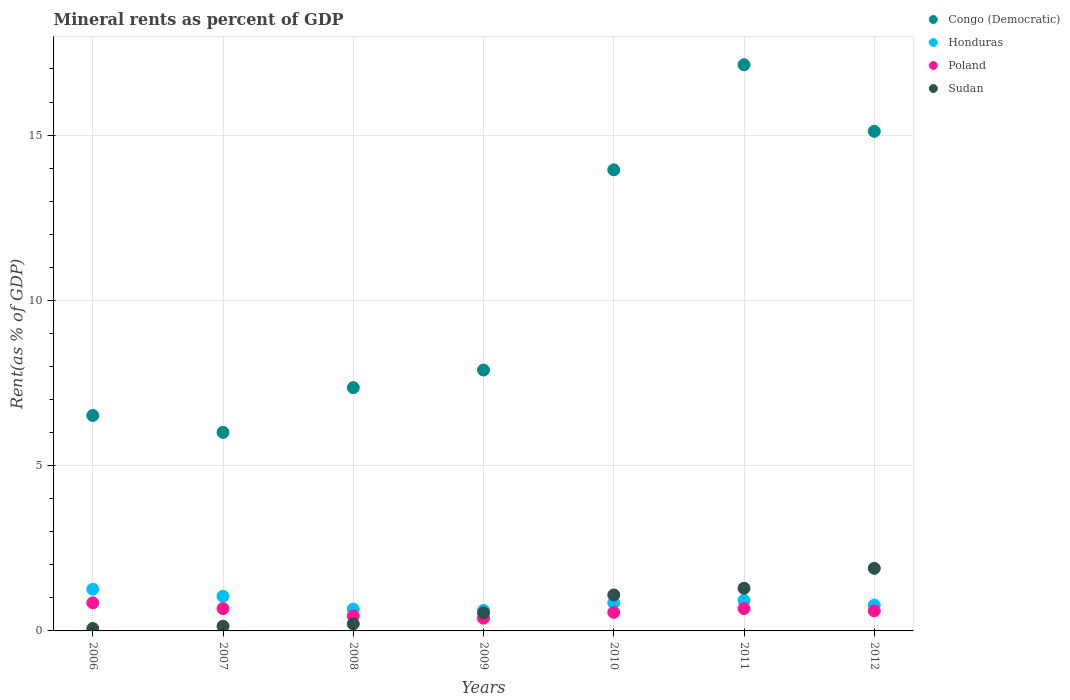How many different coloured dotlines are there?
Provide a succinct answer. 4. What is the mineral rent in Poland in 2006?
Ensure brevity in your answer.  0.85. Across all years, what is the maximum mineral rent in Poland?
Keep it short and to the point. 0.85. Across all years, what is the minimum mineral rent in Congo (Democratic)?
Keep it short and to the point. 6.01. What is the total mineral rent in Congo (Democratic) in the graph?
Ensure brevity in your answer.  73.96. What is the difference between the mineral rent in Congo (Democratic) in 2011 and that in 2012?
Your answer should be very brief. 2.01. What is the difference between the mineral rent in Sudan in 2011 and the mineral rent in Honduras in 2008?
Give a very brief answer. 0.63. What is the average mineral rent in Poland per year?
Your answer should be compact. 0.6. In the year 2010, what is the difference between the mineral rent in Honduras and mineral rent in Poland?
Provide a succinct answer. 0.29. What is the ratio of the mineral rent in Honduras in 2008 to that in 2009?
Offer a very short reply. 1.06. Is the mineral rent in Sudan in 2011 less than that in 2012?
Offer a very short reply. Yes. What is the difference between the highest and the second highest mineral rent in Honduras?
Provide a short and direct response. 0.21. What is the difference between the highest and the lowest mineral rent in Honduras?
Provide a short and direct response. 0.64. Is it the case that in every year, the sum of the mineral rent in Poland and mineral rent in Congo (Democratic)  is greater than the sum of mineral rent in Sudan and mineral rent in Honduras?
Provide a succinct answer. Yes. How many dotlines are there?
Ensure brevity in your answer.  4. Are the values on the major ticks of Y-axis written in scientific E-notation?
Ensure brevity in your answer.  No. Does the graph contain any zero values?
Make the answer very short. No. Does the graph contain grids?
Make the answer very short. Yes. Where does the legend appear in the graph?
Offer a terse response. Top right. How are the legend labels stacked?
Your answer should be compact. Vertical. What is the title of the graph?
Your response must be concise. Mineral rents as percent of GDP. What is the label or title of the Y-axis?
Keep it short and to the point. Rent(as % of GDP). What is the Rent(as % of GDP) in Congo (Democratic) in 2006?
Your answer should be very brief. 6.52. What is the Rent(as % of GDP) in Honduras in 2006?
Offer a terse response. 1.26. What is the Rent(as % of GDP) of Poland in 2006?
Your answer should be very brief. 0.85. What is the Rent(as % of GDP) of Sudan in 2006?
Offer a terse response. 0.07. What is the Rent(as % of GDP) in Congo (Democratic) in 2007?
Keep it short and to the point. 6.01. What is the Rent(as % of GDP) of Honduras in 2007?
Provide a succinct answer. 1.05. What is the Rent(as % of GDP) of Poland in 2007?
Give a very brief answer. 0.68. What is the Rent(as % of GDP) of Sudan in 2007?
Keep it short and to the point. 0.14. What is the Rent(as % of GDP) of Congo (Democratic) in 2008?
Make the answer very short. 7.36. What is the Rent(as % of GDP) of Honduras in 2008?
Keep it short and to the point. 0.66. What is the Rent(as % of GDP) in Poland in 2008?
Your answer should be very brief. 0.46. What is the Rent(as % of GDP) of Sudan in 2008?
Provide a short and direct response. 0.21. What is the Rent(as % of GDP) of Congo (Democratic) in 2009?
Offer a very short reply. 7.89. What is the Rent(as % of GDP) in Honduras in 2009?
Offer a very short reply. 0.62. What is the Rent(as % of GDP) in Poland in 2009?
Give a very brief answer. 0.39. What is the Rent(as % of GDP) in Sudan in 2009?
Offer a terse response. 0.55. What is the Rent(as % of GDP) in Congo (Democratic) in 2010?
Make the answer very short. 13.95. What is the Rent(as % of GDP) in Honduras in 2010?
Provide a short and direct response. 0.85. What is the Rent(as % of GDP) of Poland in 2010?
Provide a short and direct response. 0.56. What is the Rent(as % of GDP) in Sudan in 2010?
Ensure brevity in your answer.  1.09. What is the Rent(as % of GDP) in Congo (Democratic) in 2011?
Your response must be concise. 17.13. What is the Rent(as % of GDP) of Honduras in 2011?
Your answer should be compact. 0.92. What is the Rent(as % of GDP) of Poland in 2011?
Keep it short and to the point. 0.68. What is the Rent(as % of GDP) of Sudan in 2011?
Offer a terse response. 1.29. What is the Rent(as % of GDP) of Congo (Democratic) in 2012?
Keep it short and to the point. 15.11. What is the Rent(as % of GDP) of Honduras in 2012?
Offer a very short reply. 0.78. What is the Rent(as % of GDP) in Poland in 2012?
Your response must be concise. 0.61. What is the Rent(as % of GDP) in Sudan in 2012?
Ensure brevity in your answer.  1.89. Across all years, what is the maximum Rent(as % of GDP) in Congo (Democratic)?
Provide a succinct answer. 17.13. Across all years, what is the maximum Rent(as % of GDP) in Honduras?
Offer a very short reply. 1.26. Across all years, what is the maximum Rent(as % of GDP) of Poland?
Provide a short and direct response. 0.85. Across all years, what is the maximum Rent(as % of GDP) in Sudan?
Your response must be concise. 1.89. Across all years, what is the minimum Rent(as % of GDP) of Congo (Democratic)?
Offer a very short reply. 6.01. Across all years, what is the minimum Rent(as % of GDP) of Honduras?
Offer a very short reply. 0.62. Across all years, what is the minimum Rent(as % of GDP) of Poland?
Provide a short and direct response. 0.39. Across all years, what is the minimum Rent(as % of GDP) in Sudan?
Offer a terse response. 0.07. What is the total Rent(as % of GDP) of Congo (Democratic) in the graph?
Ensure brevity in your answer.  73.96. What is the total Rent(as % of GDP) of Honduras in the graph?
Offer a terse response. 6.15. What is the total Rent(as % of GDP) of Poland in the graph?
Your answer should be compact. 4.21. What is the total Rent(as % of GDP) of Sudan in the graph?
Your answer should be compact. 5.25. What is the difference between the Rent(as % of GDP) of Congo (Democratic) in 2006 and that in 2007?
Keep it short and to the point. 0.51. What is the difference between the Rent(as % of GDP) of Honduras in 2006 and that in 2007?
Give a very brief answer. 0.21. What is the difference between the Rent(as % of GDP) of Poland in 2006 and that in 2007?
Give a very brief answer. 0.17. What is the difference between the Rent(as % of GDP) in Sudan in 2006 and that in 2007?
Your answer should be compact. -0.07. What is the difference between the Rent(as % of GDP) in Congo (Democratic) in 2006 and that in 2008?
Give a very brief answer. -0.84. What is the difference between the Rent(as % of GDP) of Honduras in 2006 and that in 2008?
Your answer should be very brief. 0.6. What is the difference between the Rent(as % of GDP) in Poland in 2006 and that in 2008?
Your answer should be very brief. 0.39. What is the difference between the Rent(as % of GDP) of Sudan in 2006 and that in 2008?
Your response must be concise. -0.14. What is the difference between the Rent(as % of GDP) in Congo (Democratic) in 2006 and that in 2009?
Provide a succinct answer. -1.37. What is the difference between the Rent(as % of GDP) of Honduras in 2006 and that in 2009?
Offer a very short reply. 0.64. What is the difference between the Rent(as % of GDP) in Poland in 2006 and that in 2009?
Keep it short and to the point. 0.46. What is the difference between the Rent(as % of GDP) in Sudan in 2006 and that in 2009?
Offer a terse response. -0.47. What is the difference between the Rent(as % of GDP) of Congo (Democratic) in 2006 and that in 2010?
Your answer should be very brief. -7.43. What is the difference between the Rent(as % of GDP) in Honduras in 2006 and that in 2010?
Your answer should be compact. 0.41. What is the difference between the Rent(as % of GDP) of Poland in 2006 and that in 2010?
Offer a very short reply. 0.29. What is the difference between the Rent(as % of GDP) in Sudan in 2006 and that in 2010?
Offer a very short reply. -1.01. What is the difference between the Rent(as % of GDP) of Congo (Democratic) in 2006 and that in 2011?
Your answer should be very brief. -10.61. What is the difference between the Rent(as % of GDP) of Honduras in 2006 and that in 2011?
Your response must be concise. 0.34. What is the difference between the Rent(as % of GDP) in Poland in 2006 and that in 2011?
Provide a succinct answer. 0.17. What is the difference between the Rent(as % of GDP) of Sudan in 2006 and that in 2011?
Give a very brief answer. -1.22. What is the difference between the Rent(as % of GDP) in Congo (Democratic) in 2006 and that in 2012?
Give a very brief answer. -8.6. What is the difference between the Rent(as % of GDP) of Honduras in 2006 and that in 2012?
Ensure brevity in your answer.  0.48. What is the difference between the Rent(as % of GDP) in Poland in 2006 and that in 2012?
Provide a short and direct response. 0.24. What is the difference between the Rent(as % of GDP) of Sudan in 2006 and that in 2012?
Keep it short and to the point. -1.82. What is the difference between the Rent(as % of GDP) of Congo (Democratic) in 2007 and that in 2008?
Your answer should be compact. -1.35. What is the difference between the Rent(as % of GDP) in Honduras in 2007 and that in 2008?
Offer a terse response. 0.39. What is the difference between the Rent(as % of GDP) of Poland in 2007 and that in 2008?
Your answer should be very brief. 0.22. What is the difference between the Rent(as % of GDP) of Sudan in 2007 and that in 2008?
Your response must be concise. -0.07. What is the difference between the Rent(as % of GDP) in Congo (Democratic) in 2007 and that in 2009?
Ensure brevity in your answer.  -1.89. What is the difference between the Rent(as % of GDP) in Honduras in 2007 and that in 2009?
Keep it short and to the point. 0.43. What is the difference between the Rent(as % of GDP) in Poland in 2007 and that in 2009?
Offer a very short reply. 0.29. What is the difference between the Rent(as % of GDP) in Sudan in 2007 and that in 2009?
Give a very brief answer. -0.41. What is the difference between the Rent(as % of GDP) of Congo (Democratic) in 2007 and that in 2010?
Offer a terse response. -7.94. What is the difference between the Rent(as % of GDP) of Honduras in 2007 and that in 2010?
Your answer should be compact. 0.2. What is the difference between the Rent(as % of GDP) in Poland in 2007 and that in 2010?
Provide a short and direct response. 0.11. What is the difference between the Rent(as % of GDP) in Sudan in 2007 and that in 2010?
Your answer should be compact. -0.95. What is the difference between the Rent(as % of GDP) of Congo (Democratic) in 2007 and that in 2011?
Ensure brevity in your answer.  -11.12. What is the difference between the Rent(as % of GDP) of Honduras in 2007 and that in 2011?
Ensure brevity in your answer.  0.13. What is the difference between the Rent(as % of GDP) of Poland in 2007 and that in 2011?
Offer a very short reply. -0. What is the difference between the Rent(as % of GDP) in Sudan in 2007 and that in 2011?
Your answer should be compact. -1.15. What is the difference between the Rent(as % of GDP) of Congo (Democratic) in 2007 and that in 2012?
Your response must be concise. -9.11. What is the difference between the Rent(as % of GDP) in Honduras in 2007 and that in 2012?
Make the answer very short. 0.27. What is the difference between the Rent(as % of GDP) of Poland in 2007 and that in 2012?
Your answer should be very brief. 0.07. What is the difference between the Rent(as % of GDP) in Sudan in 2007 and that in 2012?
Your answer should be very brief. -1.75. What is the difference between the Rent(as % of GDP) in Congo (Democratic) in 2008 and that in 2009?
Provide a short and direct response. -0.53. What is the difference between the Rent(as % of GDP) of Honduras in 2008 and that in 2009?
Keep it short and to the point. 0.04. What is the difference between the Rent(as % of GDP) of Poland in 2008 and that in 2009?
Keep it short and to the point. 0.07. What is the difference between the Rent(as % of GDP) in Sudan in 2008 and that in 2009?
Provide a succinct answer. -0.33. What is the difference between the Rent(as % of GDP) of Congo (Democratic) in 2008 and that in 2010?
Your answer should be compact. -6.59. What is the difference between the Rent(as % of GDP) in Honduras in 2008 and that in 2010?
Offer a very short reply. -0.19. What is the difference between the Rent(as % of GDP) of Poland in 2008 and that in 2010?
Give a very brief answer. -0.1. What is the difference between the Rent(as % of GDP) of Sudan in 2008 and that in 2010?
Your answer should be very brief. -0.88. What is the difference between the Rent(as % of GDP) of Congo (Democratic) in 2008 and that in 2011?
Ensure brevity in your answer.  -9.77. What is the difference between the Rent(as % of GDP) in Honduras in 2008 and that in 2011?
Offer a terse response. -0.26. What is the difference between the Rent(as % of GDP) in Poland in 2008 and that in 2011?
Your answer should be very brief. -0.22. What is the difference between the Rent(as % of GDP) in Sudan in 2008 and that in 2011?
Provide a succinct answer. -1.08. What is the difference between the Rent(as % of GDP) of Congo (Democratic) in 2008 and that in 2012?
Provide a short and direct response. -7.75. What is the difference between the Rent(as % of GDP) in Honduras in 2008 and that in 2012?
Your answer should be compact. -0.12. What is the difference between the Rent(as % of GDP) in Poland in 2008 and that in 2012?
Offer a terse response. -0.15. What is the difference between the Rent(as % of GDP) of Sudan in 2008 and that in 2012?
Offer a terse response. -1.68. What is the difference between the Rent(as % of GDP) in Congo (Democratic) in 2009 and that in 2010?
Give a very brief answer. -6.06. What is the difference between the Rent(as % of GDP) of Honduras in 2009 and that in 2010?
Offer a very short reply. -0.23. What is the difference between the Rent(as % of GDP) of Poland in 2009 and that in 2010?
Provide a succinct answer. -0.18. What is the difference between the Rent(as % of GDP) of Sudan in 2009 and that in 2010?
Offer a very short reply. -0.54. What is the difference between the Rent(as % of GDP) of Congo (Democratic) in 2009 and that in 2011?
Provide a short and direct response. -9.24. What is the difference between the Rent(as % of GDP) in Honduras in 2009 and that in 2011?
Make the answer very short. -0.3. What is the difference between the Rent(as % of GDP) in Poland in 2009 and that in 2011?
Give a very brief answer. -0.29. What is the difference between the Rent(as % of GDP) in Sudan in 2009 and that in 2011?
Make the answer very short. -0.74. What is the difference between the Rent(as % of GDP) of Congo (Democratic) in 2009 and that in 2012?
Your answer should be compact. -7.22. What is the difference between the Rent(as % of GDP) of Honduras in 2009 and that in 2012?
Provide a short and direct response. -0.16. What is the difference between the Rent(as % of GDP) of Poland in 2009 and that in 2012?
Provide a succinct answer. -0.22. What is the difference between the Rent(as % of GDP) of Sudan in 2009 and that in 2012?
Give a very brief answer. -1.35. What is the difference between the Rent(as % of GDP) of Congo (Democratic) in 2010 and that in 2011?
Keep it short and to the point. -3.18. What is the difference between the Rent(as % of GDP) in Honduras in 2010 and that in 2011?
Make the answer very short. -0.07. What is the difference between the Rent(as % of GDP) in Poland in 2010 and that in 2011?
Your response must be concise. -0.12. What is the difference between the Rent(as % of GDP) of Sudan in 2010 and that in 2011?
Ensure brevity in your answer.  -0.2. What is the difference between the Rent(as % of GDP) in Congo (Democratic) in 2010 and that in 2012?
Offer a terse response. -1.16. What is the difference between the Rent(as % of GDP) in Honduras in 2010 and that in 2012?
Offer a very short reply. 0.07. What is the difference between the Rent(as % of GDP) in Poland in 2010 and that in 2012?
Ensure brevity in your answer.  -0.05. What is the difference between the Rent(as % of GDP) in Sudan in 2010 and that in 2012?
Your answer should be very brief. -0.81. What is the difference between the Rent(as % of GDP) of Congo (Democratic) in 2011 and that in 2012?
Ensure brevity in your answer.  2.01. What is the difference between the Rent(as % of GDP) of Honduras in 2011 and that in 2012?
Offer a terse response. 0.14. What is the difference between the Rent(as % of GDP) in Poland in 2011 and that in 2012?
Offer a terse response. 0.07. What is the difference between the Rent(as % of GDP) of Sudan in 2011 and that in 2012?
Offer a terse response. -0.6. What is the difference between the Rent(as % of GDP) in Congo (Democratic) in 2006 and the Rent(as % of GDP) in Honduras in 2007?
Your answer should be very brief. 5.47. What is the difference between the Rent(as % of GDP) in Congo (Democratic) in 2006 and the Rent(as % of GDP) in Poland in 2007?
Your response must be concise. 5.84. What is the difference between the Rent(as % of GDP) of Congo (Democratic) in 2006 and the Rent(as % of GDP) of Sudan in 2007?
Your response must be concise. 6.38. What is the difference between the Rent(as % of GDP) of Honduras in 2006 and the Rent(as % of GDP) of Poland in 2007?
Your answer should be compact. 0.59. What is the difference between the Rent(as % of GDP) of Honduras in 2006 and the Rent(as % of GDP) of Sudan in 2007?
Give a very brief answer. 1.12. What is the difference between the Rent(as % of GDP) of Poland in 2006 and the Rent(as % of GDP) of Sudan in 2007?
Make the answer very short. 0.71. What is the difference between the Rent(as % of GDP) of Congo (Democratic) in 2006 and the Rent(as % of GDP) of Honduras in 2008?
Offer a very short reply. 5.86. What is the difference between the Rent(as % of GDP) of Congo (Democratic) in 2006 and the Rent(as % of GDP) of Poland in 2008?
Provide a succinct answer. 6.06. What is the difference between the Rent(as % of GDP) in Congo (Democratic) in 2006 and the Rent(as % of GDP) in Sudan in 2008?
Provide a succinct answer. 6.3. What is the difference between the Rent(as % of GDP) of Honduras in 2006 and the Rent(as % of GDP) of Poland in 2008?
Ensure brevity in your answer.  0.8. What is the difference between the Rent(as % of GDP) of Honduras in 2006 and the Rent(as % of GDP) of Sudan in 2008?
Your response must be concise. 1.05. What is the difference between the Rent(as % of GDP) of Poland in 2006 and the Rent(as % of GDP) of Sudan in 2008?
Offer a terse response. 0.64. What is the difference between the Rent(as % of GDP) of Congo (Democratic) in 2006 and the Rent(as % of GDP) of Honduras in 2009?
Keep it short and to the point. 5.9. What is the difference between the Rent(as % of GDP) in Congo (Democratic) in 2006 and the Rent(as % of GDP) in Poland in 2009?
Keep it short and to the point. 6.13. What is the difference between the Rent(as % of GDP) in Congo (Democratic) in 2006 and the Rent(as % of GDP) in Sudan in 2009?
Your answer should be compact. 5.97. What is the difference between the Rent(as % of GDP) of Honduras in 2006 and the Rent(as % of GDP) of Poland in 2009?
Keep it short and to the point. 0.88. What is the difference between the Rent(as % of GDP) in Honduras in 2006 and the Rent(as % of GDP) in Sudan in 2009?
Offer a very short reply. 0.72. What is the difference between the Rent(as % of GDP) of Poland in 2006 and the Rent(as % of GDP) of Sudan in 2009?
Offer a very short reply. 0.3. What is the difference between the Rent(as % of GDP) of Congo (Democratic) in 2006 and the Rent(as % of GDP) of Honduras in 2010?
Make the answer very short. 5.67. What is the difference between the Rent(as % of GDP) of Congo (Democratic) in 2006 and the Rent(as % of GDP) of Poland in 2010?
Make the answer very short. 5.96. What is the difference between the Rent(as % of GDP) in Congo (Democratic) in 2006 and the Rent(as % of GDP) in Sudan in 2010?
Ensure brevity in your answer.  5.43. What is the difference between the Rent(as % of GDP) of Honduras in 2006 and the Rent(as % of GDP) of Poland in 2010?
Your answer should be compact. 0.7. What is the difference between the Rent(as % of GDP) of Honduras in 2006 and the Rent(as % of GDP) of Sudan in 2010?
Offer a terse response. 0.17. What is the difference between the Rent(as % of GDP) of Poland in 2006 and the Rent(as % of GDP) of Sudan in 2010?
Offer a terse response. -0.24. What is the difference between the Rent(as % of GDP) in Congo (Democratic) in 2006 and the Rent(as % of GDP) in Honduras in 2011?
Offer a very short reply. 5.59. What is the difference between the Rent(as % of GDP) in Congo (Democratic) in 2006 and the Rent(as % of GDP) in Poland in 2011?
Provide a short and direct response. 5.84. What is the difference between the Rent(as % of GDP) in Congo (Democratic) in 2006 and the Rent(as % of GDP) in Sudan in 2011?
Your response must be concise. 5.23. What is the difference between the Rent(as % of GDP) in Honduras in 2006 and the Rent(as % of GDP) in Poland in 2011?
Give a very brief answer. 0.59. What is the difference between the Rent(as % of GDP) of Honduras in 2006 and the Rent(as % of GDP) of Sudan in 2011?
Make the answer very short. -0.03. What is the difference between the Rent(as % of GDP) in Poland in 2006 and the Rent(as % of GDP) in Sudan in 2011?
Your answer should be compact. -0.44. What is the difference between the Rent(as % of GDP) in Congo (Democratic) in 2006 and the Rent(as % of GDP) in Honduras in 2012?
Your answer should be compact. 5.74. What is the difference between the Rent(as % of GDP) in Congo (Democratic) in 2006 and the Rent(as % of GDP) in Poland in 2012?
Ensure brevity in your answer.  5.91. What is the difference between the Rent(as % of GDP) in Congo (Democratic) in 2006 and the Rent(as % of GDP) in Sudan in 2012?
Make the answer very short. 4.62. What is the difference between the Rent(as % of GDP) of Honduras in 2006 and the Rent(as % of GDP) of Poland in 2012?
Provide a succinct answer. 0.66. What is the difference between the Rent(as % of GDP) of Honduras in 2006 and the Rent(as % of GDP) of Sudan in 2012?
Keep it short and to the point. -0.63. What is the difference between the Rent(as % of GDP) in Poland in 2006 and the Rent(as % of GDP) in Sudan in 2012?
Give a very brief answer. -1.04. What is the difference between the Rent(as % of GDP) of Congo (Democratic) in 2007 and the Rent(as % of GDP) of Honduras in 2008?
Your answer should be compact. 5.34. What is the difference between the Rent(as % of GDP) in Congo (Democratic) in 2007 and the Rent(as % of GDP) in Poland in 2008?
Your answer should be very brief. 5.55. What is the difference between the Rent(as % of GDP) of Congo (Democratic) in 2007 and the Rent(as % of GDP) of Sudan in 2008?
Make the answer very short. 5.79. What is the difference between the Rent(as % of GDP) in Honduras in 2007 and the Rent(as % of GDP) in Poland in 2008?
Your answer should be compact. 0.59. What is the difference between the Rent(as % of GDP) of Honduras in 2007 and the Rent(as % of GDP) of Sudan in 2008?
Offer a very short reply. 0.84. What is the difference between the Rent(as % of GDP) of Poland in 2007 and the Rent(as % of GDP) of Sudan in 2008?
Your answer should be very brief. 0.46. What is the difference between the Rent(as % of GDP) in Congo (Democratic) in 2007 and the Rent(as % of GDP) in Honduras in 2009?
Offer a very short reply. 5.38. What is the difference between the Rent(as % of GDP) in Congo (Democratic) in 2007 and the Rent(as % of GDP) in Poland in 2009?
Provide a short and direct response. 5.62. What is the difference between the Rent(as % of GDP) in Congo (Democratic) in 2007 and the Rent(as % of GDP) in Sudan in 2009?
Ensure brevity in your answer.  5.46. What is the difference between the Rent(as % of GDP) of Honduras in 2007 and the Rent(as % of GDP) of Poland in 2009?
Provide a short and direct response. 0.66. What is the difference between the Rent(as % of GDP) of Honduras in 2007 and the Rent(as % of GDP) of Sudan in 2009?
Keep it short and to the point. 0.5. What is the difference between the Rent(as % of GDP) of Poland in 2007 and the Rent(as % of GDP) of Sudan in 2009?
Provide a short and direct response. 0.13. What is the difference between the Rent(as % of GDP) of Congo (Democratic) in 2007 and the Rent(as % of GDP) of Honduras in 2010?
Make the answer very short. 5.16. What is the difference between the Rent(as % of GDP) in Congo (Democratic) in 2007 and the Rent(as % of GDP) in Poland in 2010?
Give a very brief answer. 5.44. What is the difference between the Rent(as % of GDP) of Congo (Democratic) in 2007 and the Rent(as % of GDP) of Sudan in 2010?
Provide a succinct answer. 4.92. What is the difference between the Rent(as % of GDP) of Honduras in 2007 and the Rent(as % of GDP) of Poland in 2010?
Offer a terse response. 0.49. What is the difference between the Rent(as % of GDP) in Honduras in 2007 and the Rent(as % of GDP) in Sudan in 2010?
Offer a very short reply. -0.04. What is the difference between the Rent(as % of GDP) of Poland in 2007 and the Rent(as % of GDP) of Sudan in 2010?
Offer a terse response. -0.41. What is the difference between the Rent(as % of GDP) of Congo (Democratic) in 2007 and the Rent(as % of GDP) of Honduras in 2011?
Ensure brevity in your answer.  5.08. What is the difference between the Rent(as % of GDP) of Congo (Democratic) in 2007 and the Rent(as % of GDP) of Poland in 2011?
Offer a terse response. 5.33. What is the difference between the Rent(as % of GDP) of Congo (Democratic) in 2007 and the Rent(as % of GDP) of Sudan in 2011?
Keep it short and to the point. 4.72. What is the difference between the Rent(as % of GDP) in Honduras in 2007 and the Rent(as % of GDP) in Poland in 2011?
Offer a terse response. 0.37. What is the difference between the Rent(as % of GDP) in Honduras in 2007 and the Rent(as % of GDP) in Sudan in 2011?
Your answer should be very brief. -0.24. What is the difference between the Rent(as % of GDP) in Poland in 2007 and the Rent(as % of GDP) in Sudan in 2011?
Keep it short and to the point. -0.61. What is the difference between the Rent(as % of GDP) in Congo (Democratic) in 2007 and the Rent(as % of GDP) in Honduras in 2012?
Keep it short and to the point. 5.22. What is the difference between the Rent(as % of GDP) in Congo (Democratic) in 2007 and the Rent(as % of GDP) in Poland in 2012?
Give a very brief answer. 5.4. What is the difference between the Rent(as % of GDP) of Congo (Democratic) in 2007 and the Rent(as % of GDP) of Sudan in 2012?
Provide a short and direct response. 4.11. What is the difference between the Rent(as % of GDP) in Honduras in 2007 and the Rent(as % of GDP) in Poland in 2012?
Your answer should be compact. 0.44. What is the difference between the Rent(as % of GDP) in Honduras in 2007 and the Rent(as % of GDP) in Sudan in 2012?
Ensure brevity in your answer.  -0.84. What is the difference between the Rent(as % of GDP) in Poland in 2007 and the Rent(as % of GDP) in Sudan in 2012?
Make the answer very short. -1.22. What is the difference between the Rent(as % of GDP) in Congo (Democratic) in 2008 and the Rent(as % of GDP) in Honduras in 2009?
Your answer should be compact. 6.74. What is the difference between the Rent(as % of GDP) in Congo (Democratic) in 2008 and the Rent(as % of GDP) in Poland in 2009?
Provide a short and direct response. 6.97. What is the difference between the Rent(as % of GDP) in Congo (Democratic) in 2008 and the Rent(as % of GDP) in Sudan in 2009?
Provide a succinct answer. 6.81. What is the difference between the Rent(as % of GDP) of Honduras in 2008 and the Rent(as % of GDP) of Poland in 2009?
Offer a very short reply. 0.28. What is the difference between the Rent(as % of GDP) in Honduras in 2008 and the Rent(as % of GDP) in Sudan in 2009?
Give a very brief answer. 0.12. What is the difference between the Rent(as % of GDP) in Poland in 2008 and the Rent(as % of GDP) in Sudan in 2009?
Your answer should be compact. -0.09. What is the difference between the Rent(as % of GDP) in Congo (Democratic) in 2008 and the Rent(as % of GDP) in Honduras in 2010?
Provide a short and direct response. 6.51. What is the difference between the Rent(as % of GDP) in Congo (Democratic) in 2008 and the Rent(as % of GDP) in Poland in 2010?
Offer a terse response. 6.8. What is the difference between the Rent(as % of GDP) in Congo (Democratic) in 2008 and the Rent(as % of GDP) in Sudan in 2010?
Your answer should be very brief. 6.27. What is the difference between the Rent(as % of GDP) of Honduras in 2008 and the Rent(as % of GDP) of Poland in 2010?
Offer a terse response. 0.1. What is the difference between the Rent(as % of GDP) of Honduras in 2008 and the Rent(as % of GDP) of Sudan in 2010?
Ensure brevity in your answer.  -0.43. What is the difference between the Rent(as % of GDP) in Poland in 2008 and the Rent(as % of GDP) in Sudan in 2010?
Your answer should be very brief. -0.63. What is the difference between the Rent(as % of GDP) in Congo (Democratic) in 2008 and the Rent(as % of GDP) in Honduras in 2011?
Your answer should be very brief. 6.44. What is the difference between the Rent(as % of GDP) of Congo (Democratic) in 2008 and the Rent(as % of GDP) of Poland in 2011?
Keep it short and to the point. 6.68. What is the difference between the Rent(as % of GDP) of Congo (Democratic) in 2008 and the Rent(as % of GDP) of Sudan in 2011?
Ensure brevity in your answer.  6.07. What is the difference between the Rent(as % of GDP) in Honduras in 2008 and the Rent(as % of GDP) in Poland in 2011?
Offer a very short reply. -0.02. What is the difference between the Rent(as % of GDP) in Honduras in 2008 and the Rent(as % of GDP) in Sudan in 2011?
Your answer should be compact. -0.63. What is the difference between the Rent(as % of GDP) in Poland in 2008 and the Rent(as % of GDP) in Sudan in 2011?
Give a very brief answer. -0.83. What is the difference between the Rent(as % of GDP) of Congo (Democratic) in 2008 and the Rent(as % of GDP) of Honduras in 2012?
Your answer should be very brief. 6.58. What is the difference between the Rent(as % of GDP) in Congo (Democratic) in 2008 and the Rent(as % of GDP) in Poland in 2012?
Your response must be concise. 6.75. What is the difference between the Rent(as % of GDP) in Congo (Democratic) in 2008 and the Rent(as % of GDP) in Sudan in 2012?
Your response must be concise. 5.47. What is the difference between the Rent(as % of GDP) in Honduras in 2008 and the Rent(as % of GDP) in Poland in 2012?
Ensure brevity in your answer.  0.05. What is the difference between the Rent(as % of GDP) in Honduras in 2008 and the Rent(as % of GDP) in Sudan in 2012?
Offer a very short reply. -1.23. What is the difference between the Rent(as % of GDP) of Poland in 2008 and the Rent(as % of GDP) of Sudan in 2012?
Provide a short and direct response. -1.44. What is the difference between the Rent(as % of GDP) in Congo (Democratic) in 2009 and the Rent(as % of GDP) in Honduras in 2010?
Provide a short and direct response. 7.04. What is the difference between the Rent(as % of GDP) in Congo (Democratic) in 2009 and the Rent(as % of GDP) in Poland in 2010?
Your answer should be very brief. 7.33. What is the difference between the Rent(as % of GDP) of Congo (Democratic) in 2009 and the Rent(as % of GDP) of Sudan in 2010?
Ensure brevity in your answer.  6.8. What is the difference between the Rent(as % of GDP) of Honduras in 2009 and the Rent(as % of GDP) of Poland in 2010?
Your answer should be very brief. 0.06. What is the difference between the Rent(as % of GDP) in Honduras in 2009 and the Rent(as % of GDP) in Sudan in 2010?
Ensure brevity in your answer.  -0.47. What is the difference between the Rent(as % of GDP) of Poland in 2009 and the Rent(as % of GDP) of Sudan in 2010?
Provide a short and direct response. -0.7. What is the difference between the Rent(as % of GDP) of Congo (Democratic) in 2009 and the Rent(as % of GDP) of Honduras in 2011?
Provide a succinct answer. 6.97. What is the difference between the Rent(as % of GDP) of Congo (Democratic) in 2009 and the Rent(as % of GDP) of Poland in 2011?
Offer a terse response. 7.21. What is the difference between the Rent(as % of GDP) in Congo (Democratic) in 2009 and the Rent(as % of GDP) in Sudan in 2011?
Your response must be concise. 6.6. What is the difference between the Rent(as % of GDP) in Honduras in 2009 and the Rent(as % of GDP) in Poland in 2011?
Give a very brief answer. -0.06. What is the difference between the Rent(as % of GDP) of Honduras in 2009 and the Rent(as % of GDP) of Sudan in 2011?
Your response must be concise. -0.67. What is the difference between the Rent(as % of GDP) of Poland in 2009 and the Rent(as % of GDP) of Sudan in 2011?
Give a very brief answer. -0.91. What is the difference between the Rent(as % of GDP) in Congo (Democratic) in 2009 and the Rent(as % of GDP) in Honduras in 2012?
Your response must be concise. 7.11. What is the difference between the Rent(as % of GDP) in Congo (Democratic) in 2009 and the Rent(as % of GDP) in Poland in 2012?
Your answer should be very brief. 7.28. What is the difference between the Rent(as % of GDP) of Congo (Democratic) in 2009 and the Rent(as % of GDP) of Sudan in 2012?
Your response must be concise. 6. What is the difference between the Rent(as % of GDP) in Honduras in 2009 and the Rent(as % of GDP) in Poland in 2012?
Provide a succinct answer. 0.01. What is the difference between the Rent(as % of GDP) of Honduras in 2009 and the Rent(as % of GDP) of Sudan in 2012?
Your response must be concise. -1.27. What is the difference between the Rent(as % of GDP) of Poland in 2009 and the Rent(as % of GDP) of Sudan in 2012?
Provide a succinct answer. -1.51. What is the difference between the Rent(as % of GDP) in Congo (Democratic) in 2010 and the Rent(as % of GDP) in Honduras in 2011?
Your response must be concise. 13.03. What is the difference between the Rent(as % of GDP) in Congo (Democratic) in 2010 and the Rent(as % of GDP) in Poland in 2011?
Provide a short and direct response. 13.27. What is the difference between the Rent(as % of GDP) of Congo (Democratic) in 2010 and the Rent(as % of GDP) of Sudan in 2011?
Keep it short and to the point. 12.66. What is the difference between the Rent(as % of GDP) in Honduras in 2010 and the Rent(as % of GDP) in Poland in 2011?
Your response must be concise. 0.17. What is the difference between the Rent(as % of GDP) of Honduras in 2010 and the Rent(as % of GDP) of Sudan in 2011?
Keep it short and to the point. -0.44. What is the difference between the Rent(as % of GDP) of Poland in 2010 and the Rent(as % of GDP) of Sudan in 2011?
Offer a very short reply. -0.73. What is the difference between the Rent(as % of GDP) in Congo (Democratic) in 2010 and the Rent(as % of GDP) in Honduras in 2012?
Provide a succinct answer. 13.17. What is the difference between the Rent(as % of GDP) in Congo (Democratic) in 2010 and the Rent(as % of GDP) in Poland in 2012?
Make the answer very short. 13.34. What is the difference between the Rent(as % of GDP) of Congo (Democratic) in 2010 and the Rent(as % of GDP) of Sudan in 2012?
Offer a terse response. 12.06. What is the difference between the Rent(as % of GDP) in Honduras in 2010 and the Rent(as % of GDP) in Poland in 2012?
Provide a short and direct response. 0.24. What is the difference between the Rent(as % of GDP) in Honduras in 2010 and the Rent(as % of GDP) in Sudan in 2012?
Ensure brevity in your answer.  -1.04. What is the difference between the Rent(as % of GDP) of Poland in 2010 and the Rent(as % of GDP) of Sudan in 2012?
Keep it short and to the point. -1.33. What is the difference between the Rent(as % of GDP) in Congo (Democratic) in 2011 and the Rent(as % of GDP) in Honduras in 2012?
Provide a short and direct response. 16.34. What is the difference between the Rent(as % of GDP) of Congo (Democratic) in 2011 and the Rent(as % of GDP) of Poland in 2012?
Give a very brief answer. 16.52. What is the difference between the Rent(as % of GDP) in Congo (Democratic) in 2011 and the Rent(as % of GDP) in Sudan in 2012?
Give a very brief answer. 15.23. What is the difference between the Rent(as % of GDP) in Honduras in 2011 and the Rent(as % of GDP) in Poland in 2012?
Provide a short and direct response. 0.32. What is the difference between the Rent(as % of GDP) of Honduras in 2011 and the Rent(as % of GDP) of Sudan in 2012?
Make the answer very short. -0.97. What is the difference between the Rent(as % of GDP) in Poland in 2011 and the Rent(as % of GDP) in Sudan in 2012?
Offer a very short reply. -1.22. What is the average Rent(as % of GDP) of Congo (Democratic) per year?
Ensure brevity in your answer.  10.57. What is the average Rent(as % of GDP) in Honduras per year?
Give a very brief answer. 0.88. What is the average Rent(as % of GDP) in Poland per year?
Make the answer very short. 0.6. What is the average Rent(as % of GDP) of Sudan per year?
Provide a short and direct response. 0.75. In the year 2006, what is the difference between the Rent(as % of GDP) in Congo (Democratic) and Rent(as % of GDP) in Honduras?
Give a very brief answer. 5.26. In the year 2006, what is the difference between the Rent(as % of GDP) of Congo (Democratic) and Rent(as % of GDP) of Poland?
Give a very brief answer. 5.67. In the year 2006, what is the difference between the Rent(as % of GDP) of Congo (Democratic) and Rent(as % of GDP) of Sudan?
Provide a short and direct response. 6.44. In the year 2006, what is the difference between the Rent(as % of GDP) in Honduras and Rent(as % of GDP) in Poland?
Your answer should be compact. 0.41. In the year 2006, what is the difference between the Rent(as % of GDP) of Honduras and Rent(as % of GDP) of Sudan?
Provide a short and direct response. 1.19. In the year 2006, what is the difference between the Rent(as % of GDP) in Poland and Rent(as % of GDP) in Sudan?
Make the answer very short. 0.78. In the year 2007, what is the difference between the Rent(as % of GDP) of Congo (Democratic) and Rent(as % of GDP) of Honduras?
Keep it short and to the point. 4.96. In the year 2007, what is the difference between the Rent(as % of GDP) of Congo (Democratic) and Rent(as % of GDP) of Poland?
Provide a succinct answer. 5.33. In the year 2007, what is the difference between the Rent(as % of GDP) of Congo (Democratic) and Rent(as % of GDP) of Sudan?
Provide a short and direct response. 5.86. In the year 2007, what is the difference between the Rent(as % of GDP) of Honduras and Rent(as % of GDP) of Poland?
Ensure brevity in your answer.  0.37. In the year 2007, what is the difference between the Rent(as % of GDP) of Honduras and Rent(as % of GDP) of Sudan?
Offer a terse response. 0.91. In the year 2007, what is the difference between the Rent(as % of GDP) in Poland and Rent(as % of GDP) in Sudan?
Ensure brevity in your answer.  0.53. In the year 2008, what is the difference between the Rent(as % of GDP) of Congo (Democratic) and Rent(as % of GDP) of Honduras?
Ensure brevity in your answer.  6.7. In the year 2008, what is the difference between the Rent(as % of GDP) in Congo (Democratic) and Rent(as % of GDP) in Poland?
Your answer should be very brief. 6.9. In the year 2008, what is the difference between the Rent(as % of GDP) of Congo (Democratic) and Rent(as % of GDP) of Sudan?
Ensure brevity in your answer.  7.15. In the year 2008, what is the difference between the Rent(as % of GDP) in Honduras and Rent(as % of GDP) in Poland?
Provide a short and direct response. 0.2. In the year 2008, what is the difference between the Rent(as % of GDP) of Honduras and Rent(as % of GDP) of Sudan?
Provide a short and direct response. 0.45. In the year 2008, what is the difference between the Rent(as % of GDP) of Poland and Rent(as % of GDP) of Sudan?
Your response must be concise. 0.25. In the year 2009, what is the difference between the Rent(as % of GDP) of Congo (Democratic) and Rent(as % of GDP) of Honduras?
Your response must be concise. 7.27. In the year 2009, what is the difference between the Rent(as % of GDP) in Congo (Democratic) and Rent(as % of GDP) in Poland?
Ensure brevity in your answer.  7.51. In the year 2009, what is the difference between the Rent(as % of GDP) in Congo (Democratic) and Rent(as % of GDP) in Sudan?
Your response must be concise. 7.35. In the year 2009, what is the difference between the Rent(as % of GDP) of Honduras and Rent(as % of GDP) of Poland?
Give a very brief answer. 0.24. In the year 2009, what is the difference between the Rent(as % of GDP) in Honduras and Rent(as % of GDP) in Sudan?
Keep it short and to the point. 0.07. In the year 2009, what is the difference between the Rent(as % of GDP) of Poland and Rent(as % of GDP) of Sudan?
Give a very brief answer. -0.16. In the year 2010, what is the difference between the Rent(as % of GDP) in Congo (Democratic) and Rent(as % of GDP) in Honduras?
Provide a short and direct response. 13.1. In the year 2010, what is the difference between the Rent(as % of GDP) of Congo (Democratic) and Rent(as % of GDP) of Poland?
Provide a short and direct response. 13.39. In the year 2010, what is the difference between the Rent(as % of GDP) of Congo (Democratic) and Rent(as % of GDP) of Sudan?
Offer a terse response. 12.86. In the year 2010, what is the difference between the Rent(as % of GDP) of Honduras and Rent(as % of GDP) of Poland?
Your answer should be very brief. 0.29. In the year 2010, what is the difference between the Rent(as % of GDP) of Honduras and Rent(as % of GDP) of Sudan?
Offer a very short reply. -0.24. In the year 2010, what is the difference between the Rent(as % of GDP) in Poland and Rent(as % of GDP) in Sudan?
Keep it short and to the point. -0.53. In the year 2011, what is the difference between the Rent(as % of GDP) in Congo (Democratic) and Rent(as % of GDP) in Honduras?
Provide a succinct answer. 16.2. In the year 2011, what is the difference between the Rent(as % of GDP) in Congo (Democratic) and Rent(as % of GDP) in Poland?
Offer a terse response. 16.45. In the year 2011, what is the difference between the Rent(as % of GDP) of Congo (Democratic) and Rent(as % of GDP) of Sudan?
Ensure brevity in your answer.  15.84. In the year 2011, what is the difference between the Rent(as % of GDP) in Honduras and Rent(as % of GDP) in Poland?
Ensure brevity in your answer.  0.25. In the year 2011, what is the difference between the Rent(as % of GDP) of Honduras and Rent(as % of GDP) of Sudan?
Your answer should be very brief. -0.37. In the year 2011, what is the difference between the Rent(as % of GDP) in Poland and Rent(as % of GDP) in Sudan?
Provide a succinct answer. -0.61. In the year 2012, what is the difference between the Rent(as % of GDP) in Congo (Democratic) and Rent(as % of GDP) in Honduras?
Offer a terse response. 14.33. In the year 2012, what is the difference between the Rent(as % of GDP) of Congo (Democratic) and Rent(as % of GDP) of Poland?
Give a very brief answer. 14.51. In the year 2012, what is the difference between the Rent(as % of GDP) of Congo (Democratic) and Rent(as % of GDP) of Sudan?
Provide a short and direct response. 13.22. In the year 2012, what is the difference between the Rent(as % of GDP) in Honduras and Rent(as % of GDP) in Poland?
Make the answer very short. 0.18. In the year 2012, what is the difference between the Rent(as % of GDP) in Honduras and Rent(as % of GDP) in Sudan?
Your answer should be compact. -1.11. In the year 2012, what is the difference between the Rent(as % of GDP) of Poland and Rent(as % of GDP) of Sudan?
Provide a succinct answer. -1.29. What is the ratio of the Rent(as % of GDP) in Congo (Democratic) in 2006 to that in 2007?
Keep it short and to the point. 1.09. What is the ratio of the Rent(as % of GDP) of Honduras in 2006 to that in 2007?
Offer a very short reply. 1.2. What is the ratio of the Rent(as % of GDP) of Poland in 2006 to that in 2007?
Provide a succinct answer. 1.26. What is the ratio of the Rent(as % of GDP) in Sudan in 2006 to that in 2007?
Provide a short and direct response. 0.53. What is the ratio of the Rent(as % of GDP) in Congo (Democratic) in 2006 to that in 2008?
Provide a short and direct response. 0.89. What is the ratio of the Rent(as % of GDP) of Honduras in 2006 to that in 2008?
Give a very brief answer. 1.91. What is the ratio of the Rent(as % of GDP) of Poland in 2006 to that in 2008?
Provide a short and direct response. 1.86. What is the ratio of the Rent(as % of GDP) in Sudan in 2006 to that in 2008?
Ensure brevity in your answer.  0.35. What is the ratio of the Rent(as % of GDP) of Congo (Democratic) in 2006 to that in 2009?
Offer a terse response. 0.83. What is the ratio of the Rent(as % of GDP) in Honduras in 2006 to that in 2009?
Your response must be concise. 2.03. What is the ratio of the Rent(as % of GDP) in Poland in 2006 to that in 2009?
Make the answer very short. 2.21. What is the ratio of the Rent(as % of GDP) in Sudan in 2006 to that in 2009?
Keep it short and to the point. 0.14. What is the ratio of the Rent(as % of GDP) in Congo (Democratic) in 2006 to that in 2010?
Your response must be concise. 0.47. What is the ratio of the Rent(as % of GDP) in Honduras in 2006 to that in 2010?
Make the answer very short. 1.49. What is the ratio of the Rent(as % of GDP) of Poland in 2006 to that in 2010?
Your response must be concise. 1.52. What is the ratio of the Rent(as % of GDP) in Sudan in 2006 to that in 2010?
Offer a terse response. 0.07. What is the ratio of the Rent(as % of GDP) of Congo (Democratic) in 2006 to that in 2011?
Provide a succinct answer. 0.38. What is the ratio of the Rent(as % of GDP) in Honduras in 2006 to that in 2011?
Provide a short and direct response. 1.37. What is the ratio of the Rent(as % of GDP) in Poland in 2006 to that in 2011?
Your answer should be compact. 1.26. What is the ratio of the Rent(as % of GDP) in Sudan in 2006 to that in 2011?
Provide a short and direct response. 0.06. What is the ratio of the Rent(as % of GDP) of Congo (Democratic) in 2006 to that in 2012?
Make the answer very short. 0.43. What is the ratio of the Rent(as % of GDP) of Honduras in 2006 to that in 2012?
Provide a succinct answer. 1.61. What is the ratio of the Rent(as % of GDP) of Poland in 2006 to that in 2012?
Give a very brief answer. 1.4. What is the ratio of the Rent(as % of GDP) of Sudan in 2006 to that in 2012?
Ensure brevity in your answer.  0.04. What is the ratio of the Rent(as % of GDP) in Congo (Democratic) in 2007 to that in 2008?
Your answer should be compact. 0.82. What is the ratio of the Rent(as % of GDP) of Honduras in 2007 to that in 2008?
Provide a short and direct response. 1.59. What is the ratio of the Rent(as % of GDP) in Poland in 2007 to that in 2008?
Your answer should be compact. 1.48. What is the ratio of the Rent(as % of GDP) in Sudan in 2007 to that in 2008?
Ensure brevity in your answer.  0.66. What is the ratio of the Rent(as % of GDP) in Congo (Democratic) in 2007 to that in 2009?
Provide a succinct answer. 0.76. What is the ratio of the Rent(as % of GDP) in Honduras in 2007 to that in 2009?
Your response must be concise. 1.69. What is the ratio of the Rent(as % of GDP) in Poland in 2007 to that in 2009?
Your response must be concise. 1.75. What is the ratio of the Rent(as % of GDP) in Sudan in 2007 to that in 2009?
Provide a succinct answer. 0.26. What is the ratio of the Rent(as % of GDP) in Congo (Democratic) in 2007 to that in 2010?
Your answer should be very brief. 0.43. What is the ratio of the Rent(as % of GDP) of Honduras in 2007 to that in 2010?
Your response must be concise. 1.24. What is the ratio of the Rent(as % of GDP) of Poland in 2007 to that in 2010?
Ensure brevity in your answer.  1.2. What is the ratio of the Rent(as % of GDP) in Sudan in 2007 to that in 2010?
Your response must be concise. 0.13. What is the ratio of the Rent(as % of GDP) in Congo (Democratic) in 2007 to that in 2011?
Give a very brief answer. 0.35. What is the ratio of the Rent(as % of GDP) in Honduras in 2007 to that in 2011?
Make the answer very short. 1.14. What is the ratio of the Rent(as % of GDP) of Poland in 2007 to that in 2011?
Keep it short and to the point. 1. What is the ratio of the Rent(as % of GDP) in Sudan in 2007 to that in 2011?
Provide a succinct answer. 0.11. What is the ratio of the Rent(as % of GDP) in Congo (Democratic) in 2007 to that in 2012?
Keep it short and to the point. 0.4. What is the ratio of the Rent(as % of GDP) of Honduras in 2007 to that in 2012?
Your response must be concise. 1.34. What is the ratio of the Rent(as % of GDP) of Poland in 2007 to that in 2012?
Offer a very short reply. 1.11. What is the ratio of the Rent(as % of GDP) in Sudan in 2007 to that in 2012?
Your response must be concise. 0.07. What is the ratio of the Rent(as % of GDP) in Congo (Democratic) in 2008 to that in 2009?
Offer a very short reply. 0.93. What is the ratio of the Rent(as % of GDP) of Honduras in 2008 to that in 2009?
Offer a very short reply. 1.06. What is the ratio of the Rent(as % of GDP) in Poland in 2008 to that in 2009?
Ensure brevity in your answer.  1.19. What is the ratio of the Rent(as % of GDP) in Sudan in 2008 to that in 2009?
Keep it short and to the point. 0.39. What is the ratio of the Rent(as % of GDP) of Congo (Democratic) in 2008 to that in 2010?
Keep it short and to the point. 0.53. What is the ratio of the Rent(as % of GDP) in Honduras in 2008 to that in 2010?
Provide a succinct answer. 0.78. What is the ratio of the Rent(as % of GDP) of Poland in 2008 to that in 2010?
Your answer should be compact. 0.82. What is the ratio of the Rent(as % of GDP) in Sudan in 2008 to that in 2010?
Offer a very short reply. 0.2. What is the ratio of the Rent(as % of GDP) of Congo (Democratic) in 2008 to that in 2011?
Provide a short and direct response. 0.43. What is the ratio of the Rent(as % of GDP) of Honduras in 2008 to that in 2011?
Offer a very short reply. 0.72. What is the ratio of the Rent(as % of GDP) of Poland in 2008 to that in 2011?
Provide a short and direct response. 0.68. What is the ratio of the Rent(as % of GDP) in Sudan in 2008 to that in 2011?
Your answer should be compact. 0.16. What is the ratio of the Rent(as % of GDP) of Congo (Democratic) in 2008 to that in 2012?
Give a very brief answer. 0.49. What is the ratio of the Rent(as % of GDP) of Honduras in 2008 to that in 2012?
Provide a succinct answer. 0.85. What is the ratio of the Rent(as % of GDP) in Poland in 2008 to that in 2012?
Ensure brevity in your answer.  0.75. What is the ratio of the Rent(as % of GDP) in Sudan in 2008 to that in 2012?
Provide a succinct answer. 0.11. What is the ratio of the Rent(as % of GDP) in Congo (Democratic) in 2009 to that in 2010?
Ensure brevity in your answer.  0.57. What is the ratio of the Rent(as % of GDP) in Honduras in 2009 to that in 2010?
Provide a short and direct response. 0.73. What is the ratio of the Rent(as % of GDP) in Poland in 2009 to that in 2010?
Ensure brevity in your answer.  0.69. What is the ratio of the Rent(as % of GDP) in Sudan in 2009 to that in 2010?
Offer a very short reply. 0.5. What is the ratio of the Rent(as % of GDP) of Congo (Democratic) in 2009 to that in 2011?
Provide a succinct answer. 0.46. What is the ratio of the Rent(as % of GDP) in Honduras in 2009 to that in 2011?
Make the answer very short. 0.67. What is the ratio of the Rent(as % of GDP) in Poland in 2009 to that in 2011?
Ensure brevity in your answer.  0.57. What is the ratio of the Rent(as % of GDP) in Sudan in 2009 to that in 2011?
Your answer should be very brief. 0.42. What is the ratio of the Rent(as % of GDP) in Congo (Democratic) in 2009 to that in 2012?
Give a very brief answer. 0.52. What is the ratio of the Rent(as % of GDP) in Honduras in 2009 to that in 2012?
Your answer should be very brief. 0.79. What is the ratio of the Rent(as % of GDP) in Poland in 2009 to that in 2012?
Ensure brevity in your answer.  0.63. What is the ratio of the Rent(as % of GDP) in Sudan in 2009 to that in 2012?
Your answer should be very brief. 0.29. What is the ratio of the Rent(as % of GDP) of Congo (Democratic) in 2010 to that in 2011?
Keep it short and to the point. 0.81. What is the ratio of the Rent(as % of GDP) in Honduras in 2010 to that in 2011?
Your answer should be very brief. 0.92. What is the ratio of the Rent(as % of GDP) in Poland in 2010 to that in 2011?
Your answer should be compact. 0.83. What is the ratio of the Rent(as % of GDP) in Sudan in 2010 to that in 2011?
Make the answer very short. 0.84. What is the ratio of the Rent(as % of GDP) of Congo (Democratic) in 2010 to that in 2012?
Make the answer very short. 0.92. What is the ratio of the Rent(as % of GDP) in Honduras in 2010 to that in 2012?
Your answer should be very brief. 1.09. What is the ratio of the Rent(as % of GDP) of Poland in 2010 to that in 2012?
Offer a very short reply. 0.92. What is the ratio of the Rent(as % of GDP) in Sudan in 2010 to that in 2012?
Provide a succinct answer. 0.57. What is the ratio of the Rent(as % of GDP) in Congo (Democratic) in 2011 to that in 2012?
Make the answer very short. 1.13. What is the ratio of the Rent(as % of GDP) in Honduras in 2011 to that in 2012?
Provide a short and direct response. 1.18. What is the ratio of the Rent(as % of GDP) of Poland in 2011 to that in 2012?
Make the answer very short. 1.12. What is the ratio of the Rent(as % of GDP) of Sudan in 2011 to that in 2012?
Make the answer very short. 0.68. What is the difference between the highest and the second highest Rent(as % of GDP) in Congo (Democratic)?
Your answer should be compact. 2.01. What is the difference between the highest and the second highest Rent(as % of GDP) of Honduras?
Provide a short and direct response. 0.21. What is the difference between the highest and the second highest Rent(as % of GDP) of Poland?
Your answer should be compact. 0.17. What is the difference between the highest and the second highest Rent(as % of GDP) of Sudan?
Your response must be concise. 0.6. What is the difference between the highest and the lowest Rent(as % of GDP) in Congo (Democratic)?
Your response must be concise. 11.12. What is the difference between the highest and the lowest Rent(as % of GDP) of Honduras?
Offer a terse response. 0.64. What is the difference between the highest and the lowest Rent(as % of GDP) in Poland?
Make the answer very short. 0.46. What is the difference between the highest and the lowest Rent(as % of GDP) in Sudan?
Offer a terse response. 1.82. 